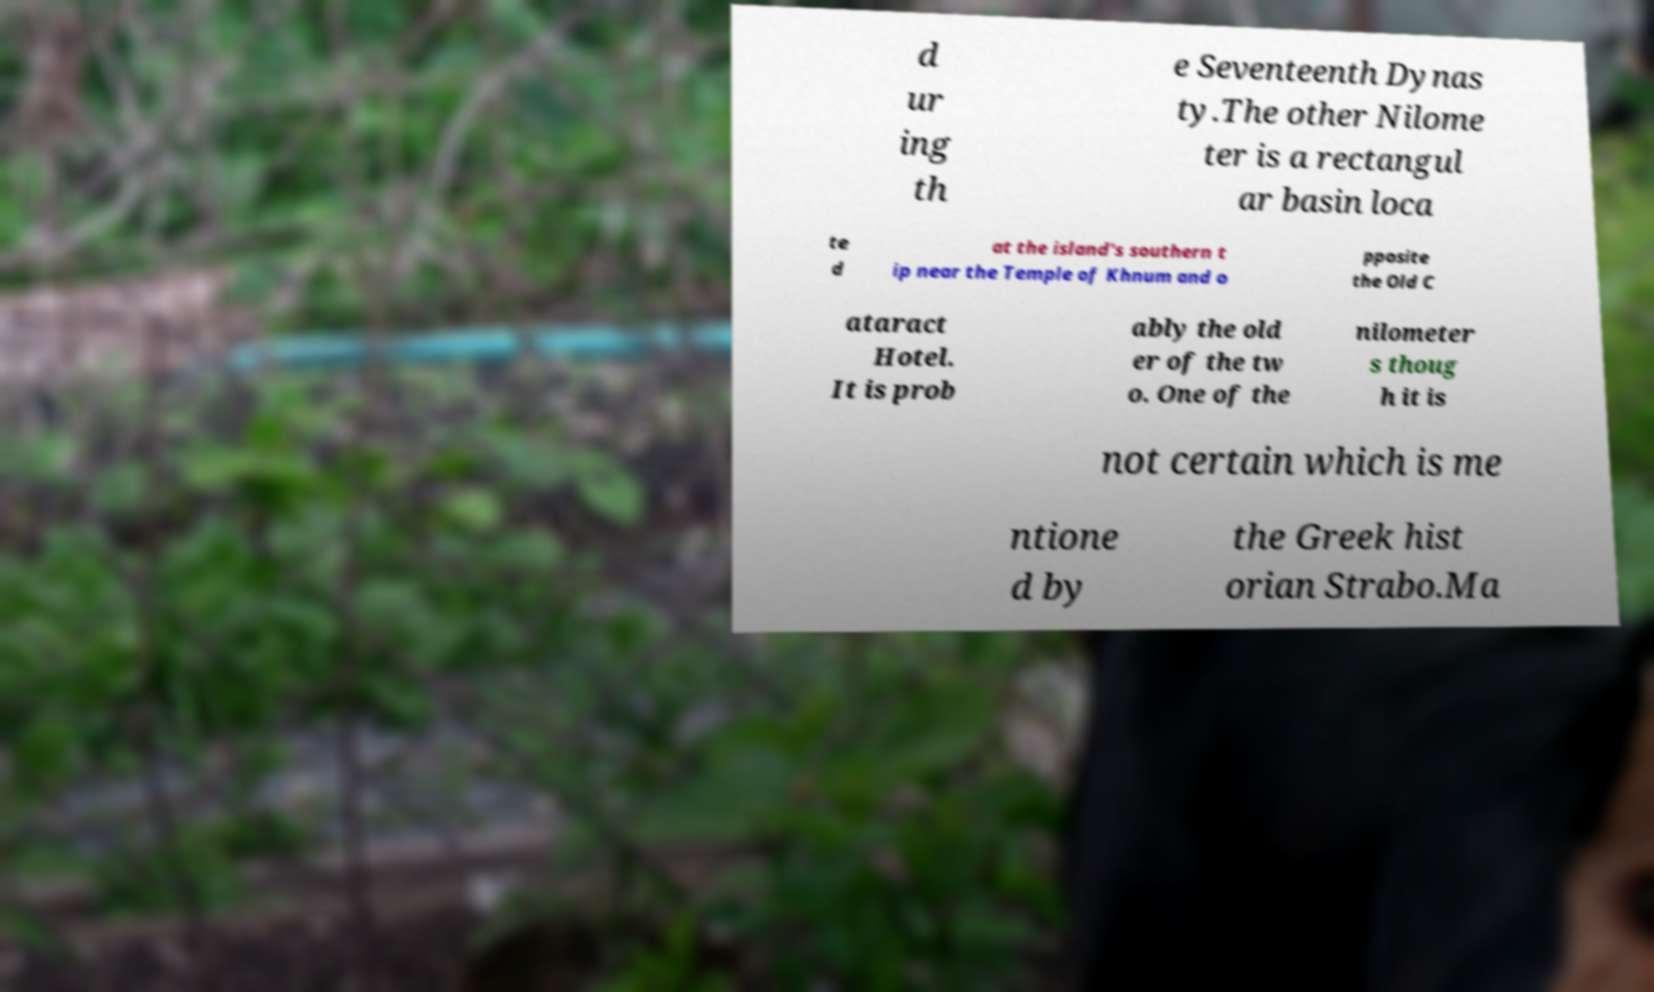Please read and relay the text visible in this image. What does it say? d ur ing th e Seventeenth Dynas ty.The other Nilome ter is a rectangul ar basin loca te d at the island's southern t ip near the Temple of Khnum and o pposite the Old C ataract Hotel. It is prob ably the old er of the tw o. One of the nilometer s thoug h it is not certain which is me ntione d by the Greek hist orian Strabo.Ma 